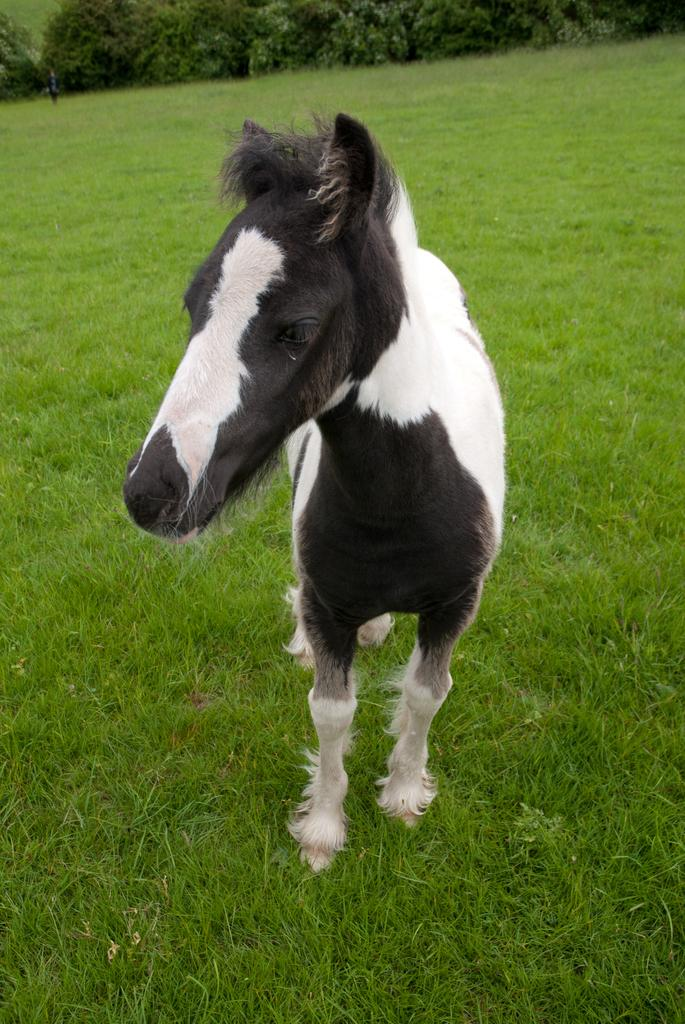What animal is present in the image? There is a horse in the image. What is the horse's position in the image? The horse is standing on the ground. What colors can be seen on the horse? The horse is black and white in color. What type of vegetation is visible in the background of the image? There is grass in the background of the image. What other natural elements can be seen in the background of the image? There are trees in the background of the image. What type of office furniture can be seen in the image? There is no office furniture present in the image; it features a black and white horse standing on the ground with grass and trees in the background. How does the jellyfish interact with the horse in the image? There is no jellyfish present in the image, so it cannot interact with the horse. 